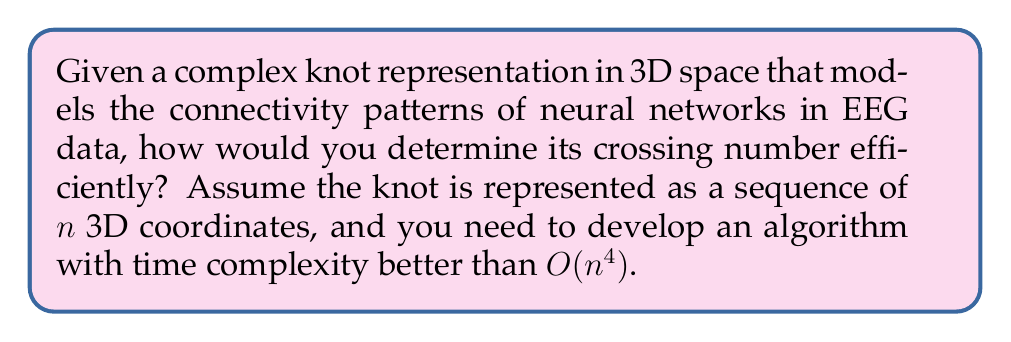What is the answer to this math problem? To determine the crossing number of a complex knot representation efficiently, we can follow these steps:

1. Projection: Project the 3D knot onto a 2D plane. This can be done by choosing a random projection direction and mapping each 3D coordinate $(x, y, z)$ to $(x', y')$ on the plane.

2. Segment Intersection: Implement a sweep line algorithm to detect all segment intersections in the 2D projection. This can be done in $O(n^2 \log n)$ time, where $n$ is the number of segments.

3. Crossing Validation: For each intersection point found in step 2, check if it represents a true crossing in the original 3D knot. This involves comparing the z-coordinates of the intersecting segments at the intersection point.

4. Counting: Keep a count of valid crossings found in step 3.

5. Optimization: Repeat steps 1-4 for multiple random projections (e.g., $k$ times) and take the minimum crossing number obtained.

The time complexity of this algorithm is $O(kn^2 \log n)$, where $k$ is the number of random projections used. This is better than the naive $O(n^4)$ approach of checking all pairs of segments for intersections in 3D space.

For EEG data analysis, this algorithm can be useful in quantifying the complexity of neural connectivity patterns. A higher crossing number may indicate more complex interactions between different brain regions.
Answer: $O(kn^2 \log n)$ time algorithm using multiple 2D projections and sweep line for intersection detection 